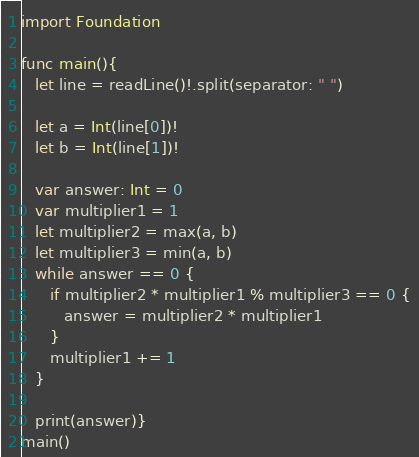<code> <loc_0><loc_0><loc_500><loc_500><_Swift_>
import Foundation

func main(){
   let line = readLine()!.split(separator: " ")
   
   let a = Int(line[0])!
   let b = Int(line[1])!
   
   var answer: Int = 0
   var multiplier1 = 1
   let multiplier2 = max(a, b)
   let multiplier3 = min(a, b)
   while answer == 0 {
      if multiplier2 * multiplier1 % multiplier3 == 0 {
         answer = multiplier2 * multiplier1
      }
      multiplier1 += 1
   }
   
   print(answer)}
main()
</code> 